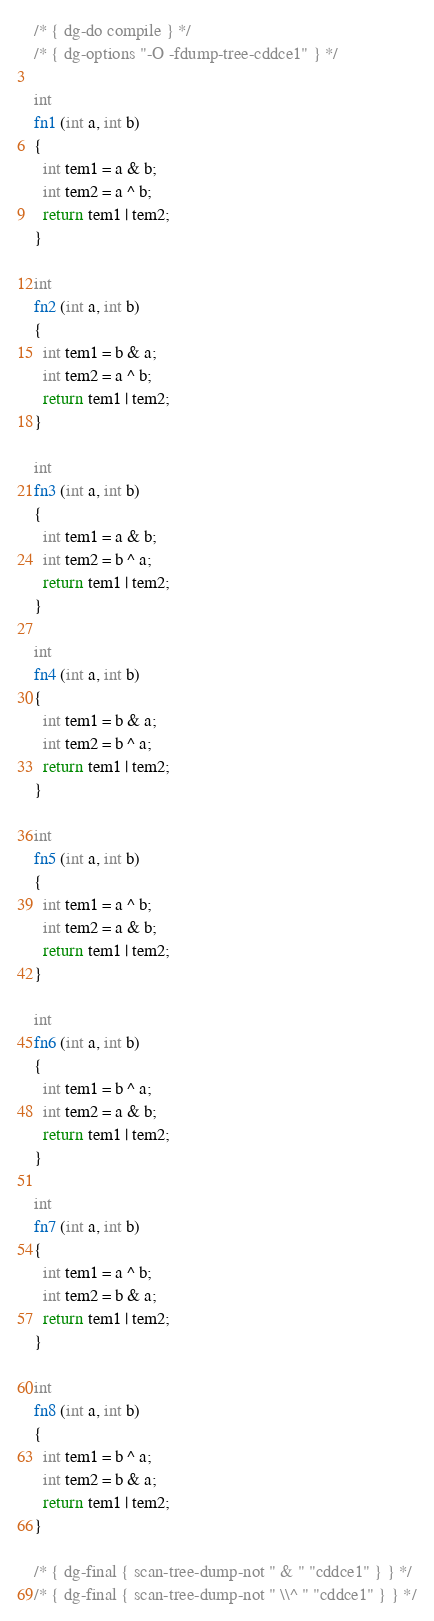Convert code to text. <code><loc_0><loc_0><loc_500><loc_500><_C_>/* { dg-do compile } */
/* { dg-options "-O -fdump-tree-cddce1" } */

int
fn1 (int a, int b)
{
  int tem1 = a & b;
  int tem2 = a ^ b;
  return tem1 | tem2;
}

int
fn2 (int a, int b)
{
  int tem1 = b & a;
  int tem2 = a ^ b;
  return tem1 | tem2;
}

int
fn3 (int a, int b)
{
  int tem1 = a & b;
  int tem2 = b ^ a;
  return tem1 | tem2;
}

int
fn4 (int a, int b)
{
  int tem1 = b & a;
  int tem2 = b ^ a;
  return tem1 | tem2;
}

int
fn5 (int a, int b)
{
  int tem1 = a ^ b;
  int tem2 = a & b;
  return tem1 | tem2;
}

int
fn6 (int a, int b)
{
  int tem1 = b ^ a;
  int tem2 = a & b;
  return tem1 | tem2;
}

int
fn7 (int a, int b)
{
  int tem1 = a ^ b;
  int tem2 = b & a;
  return tem1 | tem2;
}

int
fn8 (int a, int b)
{
  int tem1 = b ^ a;
  int tem2 = b & a;
  return tem1 | tem2;
}

/* { dg-final { scan-tree-dump-not " & " "cddce1" } } */
/* { dg-final { scan-tree-dump-not " \\^ " "cddce1" } } */
</code> 